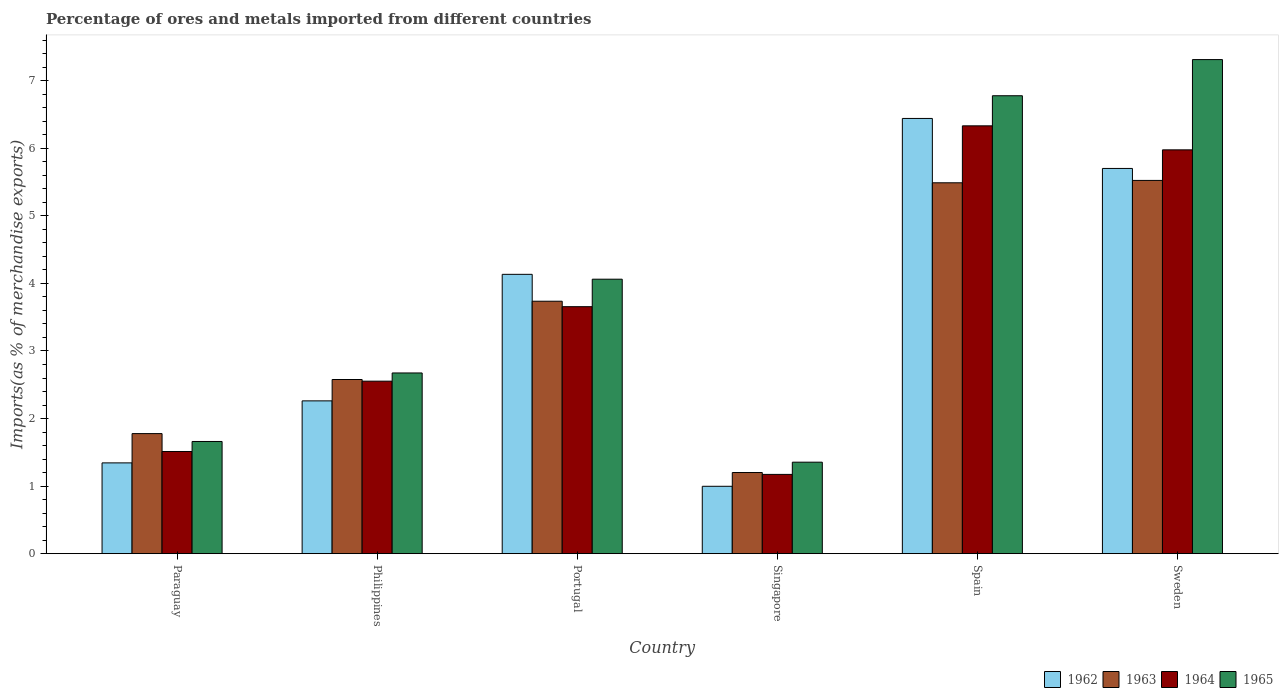How many bars are there on the 1st tick from the left?
Offer a terse response. 4. How many bars are there on the 6th tick from the right?
Your answer should be compact. 4. What is the percentage of imports to different countries in 1965 in Sweden?
Make the answer very short. 7.31. Across all countries, what is the maximum percentage of imports to different countries in 1963?
Give a very brief answer. 5.52. Across all countries, what is the minimum percentage of imports to different countries in 1963?
Make the answer very short. 1.2. In which country was the percentage of imports to different countries in 1963 minimum?
Provide a short and direct response. Singapore. What is the total percentage of imports to different countries in 1964 in the graph?
Keep it short and to the point. 21.2. What is the difference between the percentage of imports to different countries in 1965 in Philippines and that in Portugal?
Give a very brief answer. -1.39. What is the difference between the percentage of imports to different countries in 1962 in Sweden and the percentage of imports to different countries in 1965 in Spain?
Make the answer very short. -1.08. What is the average percentage of imports to different countries in 1965 per country?
Provide a short and direct response. 3.97. What is the difference between the percentage of imports to different countries of/in 1965 and percentage of imports to different countries of/in 1964 in Singapore?
Offer a very short reply. 0.18. What is the ratio of the percentage of imports to different countries in 1964 in Singapore to that in Sweden?
Keep it short and to the point. 0.2. What is the difference between the highest and the second highest percentage of imports to different countries in 1962?
Offer a very short reply. -1.57. What is the difference between the highest and the lowest percentage of imports to different countries in 1963?
Your response must be concise. 4.32. What does the 1st bar from the left in Portugal represents?
Give a very brief answer. 1962. What does the 2nd bar from the right in Spain represents?
Your answer should be compact. 1964. How many bars are there?
Your answer should be very brief. 24. What is the difference between two consecutive major ticks on the Y-axis?
Provide a short and direct response. 1. Does the graph contain grids?
Give a very brief answer. No. Where does the legend appear in the graph?
Keep it short and to the point. Bottom right. How many legend labels are there?
Provide a short and direct response. 4. What is the title of the graph?
Offer a terse response. Percentage of ores and metals imported from different countries. What is the label or title of the Y-axis?
Your answer should be very brief. Imports(as % of merchandise exports). What is the Imports(as % of merchandise exports) in 1962 in Paraguay?
Make the answer very short. 1.34. What is the Imports(as % of merchandise exports) of 1963 in Paraguay?
Offer a very short reply. 1.78. What is the Imports(as % of merchandise exports) of 1964 in Paraguay?
Give a very brief answer. 1.51. What is the Imports(as % of merchandise exports) of 1965 in Paraguay?
Provide a succinct answer. 1.66. What is the Imports(as % of merchandise exports) in 1962 in Philippines?
Provide a short and direct response. 2.26. What is the Imports(as % of merchandise exports) of 1963 in Philippines?
Your answer should be compact. 2.58. What is the Imports(as % of merchandise exports) in 1964 in Philippines?
Offer a terse response. 2.55. What is the Imports(as % of merchandise exports) of 1965 in Philippines?
Provide a short and direct response. 2.67. What is the Imports(as % of merchandise exports) of 1962 in Portugal?
Give a very brief answer. 4.13. What is the Imports(as % of merchandise exports) of 1963 in Portugal?
Offer a very short reply. 3.74. What is the Imports(as % of merchandise exports) of 1964 in Portugal?
Make the answer very short. 3.66. What is the Imports(as % of merchandise exports) in 1965 in Portugal?
Offer a very short reply. 4.06. What is the Imports(as % of merchandise exports) in 1962 in Singapore?
Your response must be concise. 1. What is the Imports(as % of merchandise exports) of 1963 in Singapore?
Your answer should be very brief. 1.2. What is the Imports(as % of merchandise exports) of 1964 in Singapore?
Offer a very short reply. 1.17. What is the Imports(as % of merchandise exports) of 1965 in Singapore?
Your response must be concise. 1.35. What is the Imports(as % of merchandise exports) of 1962 in Spain?
Your answer should be very brief. 6.44. What is the Imports(as % of merchandise exports) in 1963 in Spain?
Your answer should be compact. 5.49. What is the Imports(as % of merchandise exports) in 1964 in Spain?
Give a very brief answer. 6.33. What is the Imports(as % of merchandise exports) in 1965 in Spain?
Make the answer very short. 6.78. What is the Imports(as % of merchandise exports) of 1962 in Sweden?
Offer a very short reply. 5.7. What is the Imports(as % of merchandise exports) of 1963 in Sweden?
Your answer should be very brief. 5.52. What is the Imports(as % of merchandise exports) in 1964 in Sweden?
Offer a terse response. 5.98. What is the Imports(as % of merchandise exports) of 1965 in Sweden?
Your answer should be compact. 7.31. Across all countries, what is the maximum Imports(as % of merchandise exports) of 1962?
Your response must be concise. 6.44. Across all countries, what is the maximum Imports(as % of merchandise exports) of 1963?
Your answer should be compact. 5.52. Across all countries, what is the maximum Imports(as % of merchandise exports) of 1964?
Provide a succinct answer. 6.33. Across all countries, what is the maximum Imports(as % of merchandise exports) in 1965?
Provide a short and direct response. 7.31. Across all countries, what is the minimum Imports(as % of merchandise exports) of 1962?
Provide a short and direct response. 1. Across all countries, what is the minimum Imports(as % of merchandise exports) in 1963?
Ensure brevity in your answer.  1.2. Across all countries, what is the minimum Imports(as % of merchandise exports) in 1964?
Your answer should be very brief. 1.17. Across all countries, what is the minimum Imports(as % of merchandise exports) in 1965?
Make the answer very short. 1.35. What is the total Imports(as % of merchandise exports) of 1962 in the graph?
Provide a succinct answer. 20.88. What is the total Imports(as % of merchandise exports) in 1963 in the graph?
Offer a terse response. 20.31. What is the total Imports(as % of merchandise exports) in 1964 in the graph?
Your response must be concise. 21.2. What is the total Imports(as % of merchandise exports) of 1965 in the graph?
Ensure brevity in your answer.  23.84. What is the difference between the Imports(as % of merchandise exports) in 1962 in Paraguay and that in Philippines?
Ensure brevity in your answer.  -0.92. What is the difference between the Imports(as % of merchandise exports) in 1963 in Paraguay and that in Philippines?
Your answer should be very brief. -0.8. What is the difference between the Imports(as % of merchandise exports) of 1964 in Paraguay and that in Philippines?
Provide a short and direct response. -1.04. What is the difference between the Imports(as % of merchandise exports) in 1965 in Paraguay and that in Philippines?
Offer a very short reply. -1.01. What is the difference between the Imports(as % of merchandise exports) in 1962 in Paraguay and that in Portugal?
Provide a short and direct response. -2.79. What is the difference between the Imports(as % of merchandise exports) of 1963 in Paraguay and that in Portugal?
Keep it short and to the point. -1.96. What is the difference between the Imports(as % of merchandise exports) in 1964 in Paraguay and that in Portugal?
Offer a very short reply. -2.14. What is the difference between the Imports(as % of merchandise exports) of 1965 in Paraguay and that in Portugal?
Offer a terse response. -2.4. What is the difference between the Imports(as % of merchandise exports) of 1962 in Paraguay and that in Singapore?
Offer a terse response. 0.35. What is the difference between the Imports(as % of merchandise exports) of 1963 in Paraguay and that in Singapore?
Your answer should be compact. 0.58. What is the difference between the Imports(as % of merchandise exports) in 1964 in Paraguay and that in Singapore?
Ensure brevity in your answer.  0.34. What is the difference between the Imports(as % of merchandise exports) in 1965 in Paraguay and that in Singapore?
Provide a short and direct response. 0.31. What is the difference between the Imports(as % of merchandise exports) of 1962 in Paraguay and that in Spain?
Keep it short and to the point. -5.1. What is the difference between the Imports(as % of merchandise exports) in 1963 in Paraguay and that in Spain?
Your answer should be very brief. -3.71. What is the difference between the Imports(as % of merchandise exports) of 1964 in Paraguay and that in Spain?
Your response must be concise. -4.82. What is the difference between the Imports(as % of merchandise exports) of 1965 in Paraguay and that in Spain?
Give a very brief answer. -5.12. What is the difference between the Imports(as % of merchandise exports) of 1962 in Paraguay and that in Sweden?
Your answer should be compact. -4.36. What is the difference between the Imports(as % of merchandise exports) in 1963 in Paraguay and that in Sweden?
Provide a succinct answer. -3.75. What is the difference between the Imports(as % of merchandise exports) of 1964 in Paraguay and that in Sweden?
Make the answer very short. -4.47. What is the difference between the Imports(as % of merchandise exports) of 1965 in Paraguay and that in Sweden?
Offer a terse response. -5.65. What is the difference between the Imports(as % of merchandise exports) of 1962 in Philippines and that in Portugal?
Make the answer very short. -1.87. What is the difference between the Imports(as % of merchandise exports) in 1963 in Philippines and that in Portugal?
Make the answer very short. -1.16. What is the difference between the Imports(as % of merchandise exports) of 1964 in Philippines and that in Portugal?
Keep it short and to the point. -1.1. What is the difference between the Imports(as % of merchandise exports) of 1965 in Philippines and that in Portugal?
Give a very brief answer. -1.39. What is the difference between the Imports(as % of merchandise exports) of 1962 in Philippines and that in Singapore?
Your response must be concise. 1.26. What is the difference between the Imports(as % of merchandise exports) of 1963 in Philippines and that in Singapore?
Offer a very short reply. 1.38. What is the difference between the Imports(as % of merchandise exports) in 1964 in Philippines and that in Singapore?
Make the answer very short. 1.38. What is the difference between the Imports(as % of merchandise exports) of 1965 in Philippines and that in Singapore?
Provide a succinct answer. 1.32. What is the difference between the Imports(as % of merchandise exports) of 1962 in Philippines and that in Spain?
Provide a succinct answer. -4.18. What is the difference between the Imports(as % of merchandise exports) in 1963 in Philippines and that in Spain?
Provide a succinct answer. -2.91. What is the difference between the Imports(as % of merchandise exports) of 1964 in Philippines and that in Spain?
Ensure brevity in your answer.  -3.78. What is the difference between the Imports(as % of merchandise exports) in 1965 in Philippines and that in Spain?
Ensure brevity in your answer.  -4.1. What is the difference between the Imports(as % of merchandise exports) of 1962 in Philippines and that in Sweden?
Provide a short and direct response. -3.44. What is the difference between the Imports(as % of merchandise exports) of 1963 in Philippines and that in Sweden?
Make the answer very short. -2.95. What is the difference between the Imports(as % of merchandise exports) in 1964 in Philippines and that in Sweden?
Your answer should be very brief. -3.42. What is the difference between the Imports(as % of merchandise exports) in 1965 in Philippines and that in Sweden?
Your answer should be very brief. -4.64. What is the difference between the Imports(as % of merchandise exports) of 1962 in Portugal and that in Singapore?
Keep it short and to the point. 3.14. What is the difference between the Imports(as % of merchandise exports) of 1963 in Portugal and that in Singapore?
Offer a terse response. 2.54. What is the difference between the Imports(as % of merchandise exports) in 1964 in Portugal and that in Singapore?
Give a very brief answer. 2.48. What is the difference between the Imports(as % of merchandise exports) of 1965 in Portugal and that in Singapore?
Keep it short and to the point. 2.71. What is the difference between the Imports(as % of merchandise exports) of 1962 in Portugal and that in Spain?
Provide a succinct answer. -2.31. What is the difference between the Imports(as % of merchandise exports) in 1963 in Portugal and that in Spain?
Keep it short and to the point. -1.75. What is the difference between the Imports(as % of merchandise exports) in 1964 in Portugal and that in Spain?
Offer a terse response. -2.68. What is the difference between the Imports(as % of merchandise exports) of 1965 in Portugal and that in Spain?
Your response must be concise. -2.72. What is the difference between the Imports(as % of merchandise exports) in 1962 in Portugal and that in Sweden?
Your response must be concise. -1.57. What is the difference between the Imports(as % of merchandise exports) in 1963 in Portugal and that in Sweden?
Your answer should be compact. -1.79. What is the difference between the Imports(as % of merchandise exports) in 1964 in Portugal and that in Sweden?
Offer a terse response. -2.32. What is the difference between the Imports(as % of merchandise exports) in 1965 in Portugal and that in Sweden?
Provide a succinct answer. -3.25. What is the difference between the Imports(as % of merchandise exports) in 1962 in Singapore and that in Spain?
Your answer should be very brief. -5.45. What is the difference between the Imports(as % of merchandise exports) of 1963 in Singapore and that in Spain?
Offer a very short reply. -4.29. What is the difference between the Imports(as % of merchandise exports) of 1964 in Singapore and that in Spain?
Your answer should be compact. -5.16. What is the difference between the Imports(as % of merchandise exports) of 1965 in Singapore and that in Spain?
Your answer should be compact. -5.42. What is the difference between the Imports(as % of merchandise exports) in 1962 in Singapore and that in Sweden?
Offer a very short reply. -4.7. What is the difference between the Imports(as % of merchandise exports) of 1963 in Singapore and that in Sweden?
Keep it short and to the point. -4.32. What is the difference between the Imports(as % of merchandise exports) of 1964 in Singapore and that in Sweden?
Offer a terse response. -4.8. What is the difference between the Imports(as % of merchandise exports) in 1965 in Singapore and that in Sweden?
Your answer should be compact. -5.96. What is the difference between the Imports(as % of merchandise exports) of 1962 in Spain and that in Sweden?
Make the answer very short. 0.74. What is the difference between the Imports(as % of merchandise exports) in 1963 in Spain and that in Sweden?
Offer a very short reply. -0.04. What is the difference between the Imports(as % of merchandise exports) in 1964 in Spain and that in Sweden?
Provide a succinct answer. 0.36. What is the difference between the Imports(as % of merchandise exports) of 1965 in Spain and that in Sweden?
Provide a short and direct response. -0.54. What is the difference between the Imports(as % of merchandise exports) in 1962 in Paraguay and the Imports(as % of merchandise exports) in 1963 in Philippines?
Ensure brevity in your answer.  -1.23. What is the difference between the Imports(as % of merchandise exports) of 1962 in Paraguay and the Imports(as % of merchandise exports) of 1964 in Philippines?
Offer a very short reply. -1.21. What is the difference between the Imports(as % of merchandise exports) of 1962 in Paraguay and the Imports(as % of merchandise exports) of 1965 in Philippines?
Provide a succinct answer. -1.33. What is the difference between the Imports(as % of merchandise exports) of 1963 in Paraguay and the Imports(as % of merchandise exports) of 1964 in Philippines?
Make the answer very short. -0.78. What is the difference between the Imports(as % of merchandise exports) in 1963 in Paraguay and the Imports(as % of merchandise exports) in 1965 in Philippines?
Your answer should be compact. -0.9. What is the difference between the Imports(as % of merchandise exports) of 1964 in Paraguay and the Imports(as % of merchandise exports) of 1965 in Philippines?
Provide a short and direct response. -1.16. What is the difference between the Imports(as % of merchandise exports) of 1962 in Paraguay and the Imports(as % of merchandise exports) of 1963 in Portugal?
Provide a short and direct response. -2.39. What is the difference between the Imports(as % of merchandise exports) in 1962 in Paraguay and the Imports(as % of merchandise exports) in 1964 in Portugal?
Give a very brief answer. -2.31. What is the difference between the Imports(as % of merchandise exports) in 1962 in Paraguay and the Imports(as % of merchandise exports) in 1965 in Portugal?
Provide a short and direct response. -2.72. What is the difference between the Imports(as % of merchandise exports) of 1963 in Paraguay and the Imports(as % of merchandise exports) of 1964 in Portugal?
Keep it short and to the point. -1.88. What is the difference between the Imports(as % of merchandise exports) in 1963 in Paraguay and the Imports(as % of merchandise exports) in 1965 in Portugal?
Your answer should be very brief. -2.29. What is the difference between the Imports(as % of merchandise exports) in 1964 in Paraguay and the Imports(as % of merchandise exports) in 1965 in Portugal?
Make the answer very short. -2.55. What is the difference between the Imports(as % of merchandise exports) of 1962 in Paraguay and the Imports(as % of merchandise exports) of 1963 in Singapore?
Give a very brief answer. 0.14. What is the difference between the Imports(as % of merchandise exports) of 1962 in Paraguay and the Imports(as % of merchandise exports) of 1964 in Singapore?
Provide a succinct answer. 0.17. What is the difference between the Imports(as % of merchandise exports) in 1962 in Paraguay and the Imports(as % of merchandise exports) in 1965 in Singapore?
Keep it short and to the point. -0.01. What is the difference between the Imports(as % of merchandise exports) of 1963 in Paraguay and the Imports(as % of merchandise exports) of 1964 in Singapore?
Ensure brevity in your answer.  0.6. What is the difference between the Imports(as % of merchandise exports) in 1963 in Paraguay and the Imports(as % of merchandise exports) in 1965 in Singapore?
Provide a succinct answer. 0.42. What is the difference between the Imports(as % of merchandise exports) of 1964 in Paraguay and the Imports(as % of merchandise exports) of 1965 in Singapore?
Offer a terse response. 0.16. What is the difference between the Imports(as % of merchandise exports) of 1962 in Paraguay and the Imports(as % of merchandise exports) of 1963 in Spain?
Make the answer very short. -4.15. What is the difference between the Imports(as % of merchandise exports) in 1962 in Paraguay and the Imports(as % of merchandise exports) in 1964 in Spain?
Give a very brief answer. -4.99. What is the difference between the Imports(as % of merchandise exports) of 1962 in Paraguay and the Imports(as % of merchandise exports) of 1965 in Spain?
Keep it short and to the point. -5.43. What is the difference between the Imports(as % of merchandise exports) in 1963 in Paraguay and the Imports(as % of merchandise exports) in 1964 in Spain?
Ensure brevity in your answer.  -4.56. What is the difference between the Imports(as % of merchandise exports) of 1963 in Paraguay and the Imports(as % of merchandise exports) of 1965 in Spain?
Provide a succinct answer. -5. What is the difference between the Imports(as % of merchandise exports) of 1964 in Paraguay and the Imports(as % of merchandise exports) of 1965 in Spain?
Give a very brief answer. -5.27. What is the difference between the Imports(as % of merchandise exports) in 1962 in Paraguay and the Imports(as % of merchandise exports) in 1963 in Sweden?
Give a very brief answer. -4.18. What is the difference between the Imports(as % of merchandise exports) of 1962 in Paraguay and the Imports(as % of merchandise exports) of 1964 in Sweden?
Provide a short and direct response. -4.63. What is the difference between the Imports(as % of merchandise exports) in 1962 in Paraguay and the Imports(as % of merchandise exports) in 1965 in Sweden?
Your answer should be very brief. -5.97. What is the difference between the Imports(as % of merchandise exports) in 1963 in Paraguay and the Imports(as % of merchandise exports) in 1964 in Sweden?
Your response must be concise. -4.2. What is the difference between the Imports(as % of merchandise exports) of 1963 in Paraguay and the Imports(as % of merchandise exports) of 1965 in Sweden?
Give a very brief answer. -5.54. What is the difference between the Imports(as % of merchandise exports) of 1964 in Paraguay and the Imports(as % of merchandise exports) of 1965 in Sweden?
Keep it short and to the point. -5.8. What is the difference between the Imports(as % of merchandise exports) of 1962 in Philippines and the Imports(as % of merchandise exports) of 1963 in Portugal?
Provide a succinct answer. -1.47. What is the difference between the Imports(as % of merchandise exports) in 1962 in Philippines and the Imports(as % of merchandise exports) in 1964 in Portugal?
Provide a short and direct response. -1.39. What is the difference between the Imports(as % of merchandise exports) in 1962 in Philippines and the Imports(as % of merchandise exports) in 1965 in Portugal?
Make the answer very short. -1.8. What is the difference between the Imports(as % of merchandise exports) in 1963 in Philippines and the Imports(as % of merchandise exports) in 1964 in Portugal?
Offer a terse response. -1.08. What is the difference between the Imports(as % of merchandise exports) of 1963 in Philippines and the Imports(as % of merchandise exports) of 1965 in Portugal?
Provide a succinct answer. -1.48. What is the difference between the Imports(as % of merchandise exports) in 1964 in Philippines and the Imports(as % of merchandise exports) in 1965 in Portugal?
Provide a short and direct response. -1.51. What is the difference between the Imports(as % of merchandise exports) in 1962 in Philippines and the Imports(as % of merchandise exports) in 1963 in Singapore?
Offer a very short reply. 1.06. What is the difference between the Imports(as % of merchandise exports) of 1962 in Philippines and the Imports(as % of merchandise exports) of 1964 in Singapore?
Provide a succinct answer. 1.09. What is the difference between the Imports(as % of merchandise exports) in 1962 in Philippines and the Imports(as % of merchandise exports) in 1965 in Singapore?
Offer a very short reply. 0.91. What is the difference between the Imports(as % of merchandise exports) in 1963 in Philippines and the Imports(as % of merchandise exports) in 1964 in Singapore?
Your answer should be compact. 1.4. What is the difference between the Imports(as % of merchandise exports) of 1963 in Philippines and the Imports(as % of merchandise exports) of 1965 in Singapore?
Provide a succinct answer. 1.22. What is the difference between the Imports(as % of merchandise exports) of 1964 in Philippines and the Imports(as % of merchandise exports) of 1965 in Singapore?
Provide a succinct answer. 1.2. What is the difference between the Imports(as % of merchandise exports) in 1962 in Philippines and the Imports(as % of merchandise exports) in 1963 in Spain?
Your answer should be very brief. -3.23. What is the difference between the Imports(as % of merchandise exports) in 1962 in Philippines and the Imports(as % of merchandise exports) in 1964 in Spain?
Your response must be concise. -4.07. What is the difference between the Imports(as % of merchandise exports) in 1962 in Philippines and the Imports(as % of merchandise exports) in 1965 in Spain?
Make the answer very short. -4.52. What is the difference between the Imports(as % of merchandise exports) in 1963 in Philippines and the Imports(as % of merchandise exports) in 1964 in Spain?
Your response must be concise. -3.75. What is the difference between the Imports(as % of merchandise exports) of 1963 in Philippines and the Imports(as % of merchandise exports) of 1965 in Spain?
Your answer should be compact. -4.2. What is the difference between the Imports(as % of merchandise exports) in 1964 in Philippines and the Imports(as % of merchandise exports) in 1965 in Spain?
Your answer should be compact. -4.22. What is the difference between the Imports(as % of merchandise exports) of 1962 in Philippines and the Imports(as % of merchandise exports) of 1963 in Sweden?
Provide a short and direct response. -3.26. What is the difference between the Imports(as % of merchandise exports) of 1962 in Philippines and the Imports(as % of merchandise exports) of 1964 in Sweden?
Provide a succinct answer. -3.72. What is the difference between the Imports(as % of merchandise exports) in 1962 in Philippines and the Imports(as % of merchandise exports) in 1965 in Sweden?
Offer a terse response. -5.05. What is the difference between the Imports(as % of merchandise exports) in 1963 in Philippines and the Imports(as % of merchandise exports) in 1964 in Sweden?
Offer a terse response. -3.4. What is the difference between the Imports(as % of merchandise exports) in 1963 in Philippines and the Imports(as % of merchandise exports) in 1965 in Sweden?
Make the answer very short. -4.74. What is the difference between the Imports(as % of merchandise exports) of 1964 in Philippines and the Imports(as % of merchandise exports) of 1965 in Sweden?
Your answer should be compact. -4.76. What is the difference between the Imports(as % of merchandise exports) of 1962 in Portugal and the Imports(as % of merchandise exports) of 1963 in Singapore?
Your answer should be very brief. 2.93. What is the difference between the Imports(as % of merchandise exports) in 1962 in Portugal and the Imports(as % of merchandise exports) in 1964 in Singapore?
Your response must be concise. 2.96. What is the difference between the Imports(as % of merchandise exports) of 1962 in Portugal and the Imports(as % of merchandise exports) of 1965 in Singapore?
Your response must be concise. 2.78. What is the difference between the Imports(as % of merchandise exports) in 1963 in Portugal and the Imports(as % of merchandise exports) in 1964 in Singapore?
Ensure brevity in your answer.  2.56. What is the difference between the Imports(as % of merchandise exports) of 1963 in Portugal and the Imports(as % of merchandise exports) of 1965 in Singapore?
Provide a succinct answer. 2.38. What is the difference between the Imports(as % of merchandise exports) in 1964 in Portugal and the Imports(as % of merchandise exports) in 1965 in Singapore?
Your response must be concise. 2.3. What is the difference between the Imports(as % of merchandise exports) in 1962 in Portugal and the Imports(as % of merchandise exports) in 1963 in Spain?
Provide a succinct answer. -1.36. What is the difference between the Imports(as % of merchandise exports) in 1962 in Portugal and the Imports(as % of merchandise exports) in 1964 in Spain?
Ensure brevity in your answer.  -2.2. What is the difference between the Imports(as % of merchandise exports) in 1962 in Portugal and the Imports(as % of merchandise exports) in 1965 in Spain?
Your answer should be very brief. -2.64. What is the difference between the Imports(as % of merchandise exports) of 1963 in Portugal and the Imports(as % of merchandise exports) of 1964 in Spain?
Your response must be concise. -2.6. What is the difference between the Imports(as % of merchandise exports) of 1963 in Portugal and the Imports(as % of merchandise exports) of 1965 in Spain?
Keep it short and to the point. -3.04. What is the difference between the Imports(as % of merchandise exports) of 1964 in Portugal and the Imports(as % of merchandise exports) of 1965 in Spain?
Your answer should be compact. -3.12. What is the difference between the Imports(as % of merchandise exports) in 1962 in Portugal and the Imports(as % of merchandise exports) in 1963 in Sweden?
Keep it short and to the point. -1.39. What is the difference between the Imports(as % of merchandise exports) in 1962 in Portugal and the Imports(as % of merchandise exports) in 1964 in Sweden?
Provide a short and direct response. -1.84. What is the difference between the Imports(as % of merchandise exports) of 1962 in Portugal and the Imports(as % of merchandise exports) of 1965 in Sweden?
Your answer should be very brief. -3.18. What is the difference between the Imports(as % of merchandise exports) in 1963 in Portugal and the Imports(as % of merchandise exports) in 1964 in Sweden?
Give a very brief answer. -2.24. What is the difference between the Imports(as % of merchandise exports) of 1963 in Portugal and the Imports(as % of merchandise exports) of 1965 in Sweden?
Make the answer very short. -3.58. What is the difference between the Imports(as % of merchandise exports) in 1964 in Portugal and the Imports(as % of merchandise exports) in 1965 in Sweden?
Provide a succinct answer. -3.66. What is the difference between the Imports(as % of merchandise exports) of 1962 in Singapore and the Imports(as % of merchandise exports) of 1963 in Spain?
Your answer should be compact. -4.49. What is the difference between the Imports(as % of merchandise exports) of 1962 in Singapore and the Imports(as % of merchandise exports) of 1964 in Spain?
Your answer should be very brief. -5.34. What is the difference between the Imports(as % of merchandise exports) in 1962 in Singapore and the Imports(as % of merchandise exports) in 1965 in Spain?
Keep it short and to the point. -5.78. What is the difference between the Imports(as % of merchandise exports) in 1963 in Singapore and the Imports(as % of merchandise exports) in 1964 in Spain?
Offer a very short reply. -5.13. What is the difference between the Imports(as % of merchandise exports) in 1963 in Singapore and the Imports(as % of merchandise exports) in 1965 in Spain?
Provide a succinct answer. -5.58. What is the difference between the Imports(as % of merchandise exports) of 1964 in Singapore and the Imports(as % of merchandise exports) of 1965 in Spain?
Make the answer very short. -5.61. What is the difference between the Imports(as % of merchandise exports) in 1962 in Singapore and the Imports(as % of merchandise exports) in 1963 in Sweden?
Offer a very short reply. -4.53. What is the difference between the Imports(as % of merchandise exports) of 1962 in Singapore and the Imports(as % of merchandise exports) of 1964 in Sweden?
Ensure brevity in your answer.  -4.98. What is the difference between the Imports(as % of merchandise exports) of 1962 in Singapore and the Imports(as % of merchandise exports) of 1965 in Sweden?
Make the answer very short. -6.32. What is the difference between the Imports(as % of merchandise exports) of 1963 in Singapore and the Imports(as % of merchandise exports) of 1964 in Sweden?
Offer a very short reply. -4.78. What is the difference between the Imports(as % of merchandise exports) in 1963 in Singapore and the Imports(as % of merchandise exports) in 1965 in Sweden?
Offer a very short reply. -6.11. What is the difference between the Imports(as % of merchandise exports) of 1964 in Singapore and the Imports(as % of merchandise exports) of 1965 in Sweden?
Your response must be concise. -6.14. What is the difference between the Imports(as % of merchandise exports) of 1962 in Spain and the Imports(as % of merchandise exports) of 1963 in Sweden?
Make the answer very short. 0.92. What is the difference between the Imports(as % of merchandise exports) in 1962 in Spain and the Imports(as % of merchandise exports) in 1964 in Sweden?
Ensure brevity in your answer.  0.47. What is the difference between the Imports(as % of merchandise exports) of 1962 in Spain and the Imports(as % of merchandise exports) of 1965 in Sweden?
Your answer should be very brief. -0.87. What is the difference between the Imports(as % of merchandise exports) of 1963 in Spain and the Imports(as % of merchandise exports) of 1964 in Sweden?
Your answer should be compact. -0.49. What is the difference between the Imports(as % of merchandise exports) of 1963 in Spain and the Imports(as % of merchandise exports) of 1965 in Sweden?
Offer a very short reply. -1.82. What is the difference between the Imports(as % of merchandise exports) in 1964 in Spain and the Imports(as % of merchandise exports) in 1965 in Sweden?
Your answer should be compact. -0.98. What is the average Imports(as % of merchandise exports) in 1962 per country?
Offer a terse response. 3.48. What is the average Imports(as % of merchandise exports) of 1963 per country?
Your response must be concise. 3.38. What is the average Imports(as % of merchandise exports) of 1964 per country?
Your response must be concise. 3.53. What is the average Imports(as % of merchandise exports) of 1965 per country?
Keep it short and to the point. 3.97. What is the difference between the Imports(as % of merchandise exports) in 1962 and Imports(as % of merchandise exports) in 1963 in Paraguay?
Give a very brief answer. -0.43. What is the difference between the Imports(as % of merchandise exports) of 1962 and Imports(as % of merchandise exports) of 1964 in Paraguay?
Provide a succinct answer. -0.17. What is the difference between the Imports(as % of merchandise exports) in 1962 and Imports(as % of merchandise exports) in 1965 in Paraguay?
Keep it short and to the point. -0.32. What is the difference between the Imports(as % of merchandise exports) in 1963 and Imports(as % of merchandise exports) in 1964 in Paraguay?
Your answer should be compact. 0.26. What is the difference between the Imports(as % of merchandise exports) in 1963 and Imports(as % of merchandise exports) in 1965 in Paraguay?
Ensure brevity in your answer.  0.12. What is the difference between the Imports(as % of merchandise exports) in 1964 and Imports(as % of merchandise exports) in 1965 in Paraguay?
Give a very brief answer. -0.15. What is the difference between the Imports(as % of merchandise exports) in 1962 and Imports(as % of merchandise exports) in 1963 in Philippines?
Your answer should be very brief. -0.32. What is the difference between the Imports(as % of merchandise exports) in 1962 and Imports(as % of merchandise exports) in 1964 in Philippines?
Ensure brevity in your answer.  -0.29. What is the difference between the Imports(as % of merchandise exports) in 1962 and Imports(as % of merchandise exports) in 1965 in Philippines?
Ensure brevity in your answer.  -0.41. What is the difference between the Imports(as % of merchandise exports) in 1963 and Imports(as % of merchandise exports) in 1964 in Philippines?
Provide a succinct answer. 0.02. What is the difference between the Imports(as % of merchandise exports) in 1963 and Imports(as % of merchandise exports) in 1965 in Philippines?
Make the answer very short. -0.1. What is the difference between the Imports(as % of merchandise exports) in 1964 and Imports(as % of merchandise exports) in 1965 in Philippines?
Ensure brevity in your answer.  -0.12. What is the difference between the Imports(as % of merchandise exports) in 1962 and Imports(as % of merchandise exports) in 1963 in Portugal?
Offer a terse response. 0.4. What is the difference between the Imports(as % of merchandise exports) of 1962 and Imports(as % of merchandise exports) of 1964 in Portugal?
Provide a short and direct response. 0.48. What is the difference between the Imports(as % of merchandise exports) in 1962 and Imports(as % of merchandise exports) in 1965 in Portugal?
Keep it short and to the point. 0.07. What is the difference between the Imports(as % of merchandise exports) in 1963 and Imports(as % of merchandise exports) in 1964 in Portugal?
Keep it short and to the point. 0.08. What is the difference between the Imports(as % of merchandise exports) of 1963 and Imports(as % of merchandise exports) of 1965 in Portugal?
Provide a succinct answer. -0.33. What is the difference between the Imports(as % of merchandise exports) in 1964 and Imports(as % of merchandise exports) in 1965 in Portugal?
Keep it short and to the point. -0.41. What is the difference between the Imports(as % of merchandise exports) in 1962 and Imports(as % of merchandise exports) in 1963 in Singapore?
Offer a terse response. -0.2. What is the difference between the Imports(as % of merchandise exports) of 1962 and Imports(as % of merchandise exports) of 1964 in Singapore?
Ensure brevity in your answer.  -0.18. What is the difference between the Imports(as % of merchandise exports) of 1962 and Imports(as % of merchandise exports) of 1965 in Singapore?
Keep it short and to the point. -0.36. What is the difference between the Imports(as % of merchandise exports) in 1963 and Imports(as % of merchandise exports) in 1964 in Singapore?
Offer a very short reply. 0.03. What is the difference between the Imports(as % of merchandise exports) of 1963 and Imports(as % of merchandise exports) of 1965 in Singapore?
Provide a succinct answer. -0.15. What is the difference between the Imports(as % of merchandise exports) of 1964 and Imports(as % of merchandise exports) of 1965 in Singapore?
Your answer should be compact. -0.18. What is the difference between the Imports(as % of merchandise exports) of 1962 and Imports(as % of merchandise exports) of 1964 in Spain?
Offer a terse response. 0.11. What is the difference between the Imports(as % of merchandise exports) of 1962 and Imports(as % of merchandise exports) of 1965 in Spain?
Make the answer very short. -0.34. What is the difference between the Imports(as % of merchandise exports) in 1963 and Imports(as % of merchandise exports) in 1964 in Spain?
Make the answer very short. -0.84. What is the difference between the Imports(as % of merchandise exports) in 1963 and Imports(as % of merchandise exports) in 1965 in Spain?
Offer a terse response. -1.29. What is the difference between the Imports(as % of merchandise exports) of 1964 and Imports(as % of merchandise exports) of 1965 in Spain?
Make the answer very short. -0.45. What is the difference between the Imports(as % of merchandise exports) in 1962 and Imports(as % of merchandise exports) in 1963 in Sweden?
Your answer should be compact. 0.18. What is the difference between the Imports(as % of merchandise exports) in 1962 and Imports(as % of merchandise exports) in 1964 in Sweden?
Your answer should be compact. -0.28. What is the difference between the Imports(as % of merchandise exports) in 1962 and Imports(as % of merchandise exports) in 1965 in Sweden?
Offer a terse response. -1.61. What is the difference between the Imports(as % of merchandise exports) of 1963 and Imports(as % of merchandise exports) of 1964 in Sweden?
Make the answer very short. -0.45. What is the difference between the Imports(as % of merchandise exports) of 1963 and Imports(as % of merchandise exports) of 1965 in Sweden?
Make the answer very short. -1.79. What is the difference between the Imports(as % of merchandise exports) in 1964 and Imports(as % of merchandise exports) in 1965 in Sweden?
Keep it short and to the point. -1.34. What is the ratio of the Imports(as % of merchandise exports) of 1962 in Paraguay to that in Philippines?
Your answer should be very brief. 0.59. What is the ratio of the Imports(as % of merchandise exports) of 1963 in Paraguay to that in Philippines?
Offer a terse response. 0.69. What is the ratio of the Imports(as % of merchandise exports) in 1964 in Paraguay to that in Philippines?
Make the answer very short. 0.59. What is the ratio of the Imports(as % of merchandise exports) in 1965 in Paraguay to that in Philippines?
Your response must be concise. 0.62. What is the ratio of the Imports(as % of merchandise exports) of 1962 in Paraguay to that in Portugal?
Give a very brief answer. 0.33. What is the ratio of the Imports(as % of merchandise exports) in 1963 in Paraguay to that in Portugal?
Make the answer very short. 0.48. What is the ratio of the Imports(as % of merchandise exports) in 1964 in Paraguay to that in Portugal?
Provide a succinct answer. 0.41. What is the ratio of the Imports(as % of merchandise exports) in 1965 in Paraguay to that in Portugal?
Your answer should be compact. 0.41. What is the ratio of the Imports(as % of merchandise exports) of 1962 in Paraguay to that in Singapore?
Offer a very short reply. 1.35. What is the ratio of the Imports(as % of merchandise exports) in 1963 in Paraguay to that in Singapore?
Give a very brief answer. 1.48. What is the ratio of the Imports(as % of merchandise exports) in 1964 in Paraguay to that in Singapore?
Offer a very short reply. 1.29. What is the ratio of the Imports(as % of merchandise exports) in 1965 in Paraguay to that in Singapore?
Provide a succinct answer. 1.23. What is the ratio of the Imports(as % of merchandise exports) of 1962 in Paraguay to that in Spain?
Provide a short and direct response. 0.21. What is the ratio of the Imports(as % of merchandise exports) in 1963 in Paraguay to that in Spain?
Ensure brevity in your answer.  0.32. What is the ratio of the Imports(as % of merchandise exports) of 1964 in Paraguay to that in Spain?
Offer a very short reply. 0.24. What is the ratio of the Imports(as % of merchandise exports) in 1965 in Paraguay to that in Spain?
Your answer should be very brief. 0.24. What is the ratio of the Imports(as % of merchandise exports) of 1962 in Paraguay to that in Sweden?
Give a very brief answer. 0.24. What is the ratio of the Imports(as % of merchandise exports) in 1963 in Paraguay to that in Sweden?
Your answer should be compact. 0.32. What is the ratio of the Imports(as % of merchandise exports) of 1964 in Paraguay to that in Sweden?
Offer a very short reply. 0.25. What is the ratio of the Imports(as % of merchandise exports) in 1965 in Paraguay to that in Sweden?
Your answer should be compact. 0.23. What is the ratio of the Imports(as % of merchandise exports) of 1962 in Philippines to that in Portugal?
Give a very brief answer. 0.55. What is the ratio of the Imports(as % of merchandise exports) in 1963 in Philippines to that in Portugal?
Offer a terse response. 0.69. What is the ratio of the Imports(as % of merchandise exports) of 1964 in Philippines to that in Portugal?
Your answer should be very brief. 0.7. What is the ratio of the Imports(as % of merchandise exports) in 1965 in Philippines to that in Portugal?
Give a very brief answer. 0.66. What is the ratio of the Imports(as % of merchandise exports) in 1962 in Philippines to that in Singapore?
Offer a terse response. 2.27. What is the ratio of the Imports(as % of merchandise exports) of 1963 in Philippines to that in Singapore?
Offer a very short reply. 2.15. What is the ratio of the Imports(as % of merchandise exports) of 1964 in Philippines to that in Singapore?
Your response must be concise. 2.18. What is the ratio of the Imports(as % of merchandise exports) in 1965 in Philippines to that in Singapore?
Offer a terse response. 1.98. What is the ratio of the Imports(as % of merchandise exports) of 1962 in Philippines to that in Spain?
Provide a succinct answer. 0.35. What is the ratio of the Imports(as % of merchandise exports) in 1963 in Philippines to that in Spain?
Offer a terse response. 0.47. What is the ratio of the Imports(as % of merchandise exports) of 1964 in Philippines to that in Spain?
Keep it short and to the point. 0.4. What is the ratio of the Imports(as % of merchandise exports) of 1965 in Philippines to that in Spain?
Your answer should be compact. 0.39. What is the ratio of the Imports(as % of merchandise exports) of 1962 in Philippines to that in Sweden?
Keep it short and to the point. 0.4. What is the ratio of the Imports(as % of merchandise exports) in 1963 in Philippines to that in Sweden?
Keep it short and to the point. 0.47. What is the ratio of the Imports(as % of merchandise exports) of 1964 in Philippines to that in Sweden?
Give a very brief answer. 0.43. What is the ratio of the Imports(as % of merchandise exports) of 1965 in Philippines to that in Sweden?
Your response must be concise. 0.37. What is the ratio of the Imports(as % of merchandise exports) of 1962 in Portugal to that in Singapore?
Offer a very short reply. 4.15. What is the ratio of the Imports(as % of merchandise exports) of 1963 in Portugal to that in Singapore?
Offer a terse response. 3.11. What is the ratio of the Imports(as % of merchandise exports) in 1964 in Portugal to that in Singapore?
Provide a short and direct response. 3.12. What is the ratio of the Imports(as % of merchandise exports) of 1965 in Portugal to that in Singapore?
Offer a terse response. 3. What is the ratio of the Imports(as % of merchandise exports) of 1962 in Portugal to that in Spain?
Provide a short and direct response. 0.64. What is the ratio of the Imports(as % of merchandise exports) of 1963 in Portugal to that in Spain?
Your answer should be very brief. 0.68. What is the ratio of the Imports(as % of merchandise exports) in 1964 in Portugal to that in Spain?
Keep it short and to the point. 0.58. What is the ratio of the Imports(as % of merchandise exports) of 1965 in Portugal to that in Spain?
Your answer should be compact. 0.6. What is the ratio of the Imports(as % of merchandise exports) in 1962 in Portugal to that in Sweden?
Keep it short and to the point. 0.73. What is the ratio of the Imports(as % of merchandise exports) in 1963 in Portugal to that in Sweden?
Give a very brief answer. 0.68. What is the ratio of the Imports(as % of merchandise exports) in 1964 in Portugal to that in Sweden?
Your answer should be very brief. 0.61. What is the ratio of the Imports(as % of merchandise exports) in 1965 in Portugal to that in Sweden?
Your answer should be compact. 0.56. What is the ratio of the Imports(as % of merchandise exports) in 1962 in Singapore to that in Spain?
Give a very brief answer. 0.15. What is the ratio of the Imports(as % of merchandise exports) of 1963 in Singapore to that in Spain?
Your answer should be very brief. 0.22. What is the ratio of the Imports(as % of merchandise exports) in 1964 in Singapore to that in Spain?
Provide a succinct answer. 0.19. What is the ratio of the Imports(as % of merchandise exports) in 1965 in Singapore to that in Spain?
Provide a short and direct response. 0.2. What is the ratio of the Imports(as % of merchandise exports) in 1962 in Singapore to that in Sweden?
Offer a very short reply. 0.17. What is the ratio of the Imports(as % of merchandise exports) of 1963 in Singapore to that in Sweden?
Offer a very short reply. 0.22. What is the ratio of the Imports(as % of merchandise exports) of 1964 in Singapore to that in Sweden?
Give a very brief answer. 0.2. What is the ratio of the Imports(as % of merchandise exports) in 1965 in Singapore to that in Sweden?
Provide a succinct answer. 0.19. What is the ratio of the Imports(as % of merchandise exports) in 1962 in Spain to that in Sweden?
Provide a short and direct response. 1.13. What is the ratio of the Imports(as % of merchandise exports) of 1964 in Spain to that in Sweden?
Make the answer very short. 1.06. What is the ratio of the Imports(as % of merchandise exports) of 1965 in Spain to that in Sweden?
Offer a terse response. 0.93. What is the difference between the highest and the second highest Imports(as % of merchandise exports) in 1962?
Your answer should be compact. 0.74. What is the difference between the highest and the second highest Imports(as % of merchandise exports) of 1963?
Give a very brief answer. 0.04. What is the difference between the highest and the second highest Imports(as % of merchandise exports) in 1964?
Provide a short and direct response. 0.36. What is the difference between the highest and the second highest Imports(as % of merchandise exports) in 1965?
Provide a succinct answer. 0.54. What is the difference between the highest and the lowest Imports(as % of merchandise exports) in 1962?
Offer a very short reply. 5.45. What is the difference between the highest and the lowest Imports(as % of merchandise exports) of 1963?
Offer a terse response. 4.32. What is the difference between the highest and the lowest Imports(as % of merchandise exports) of 1964?
Your answer should be very brief. 5.16. What is the difference between the highest and the lowest Imports(as % of merchandise exports) of 1965?
Make the answer very short. 5.96. 